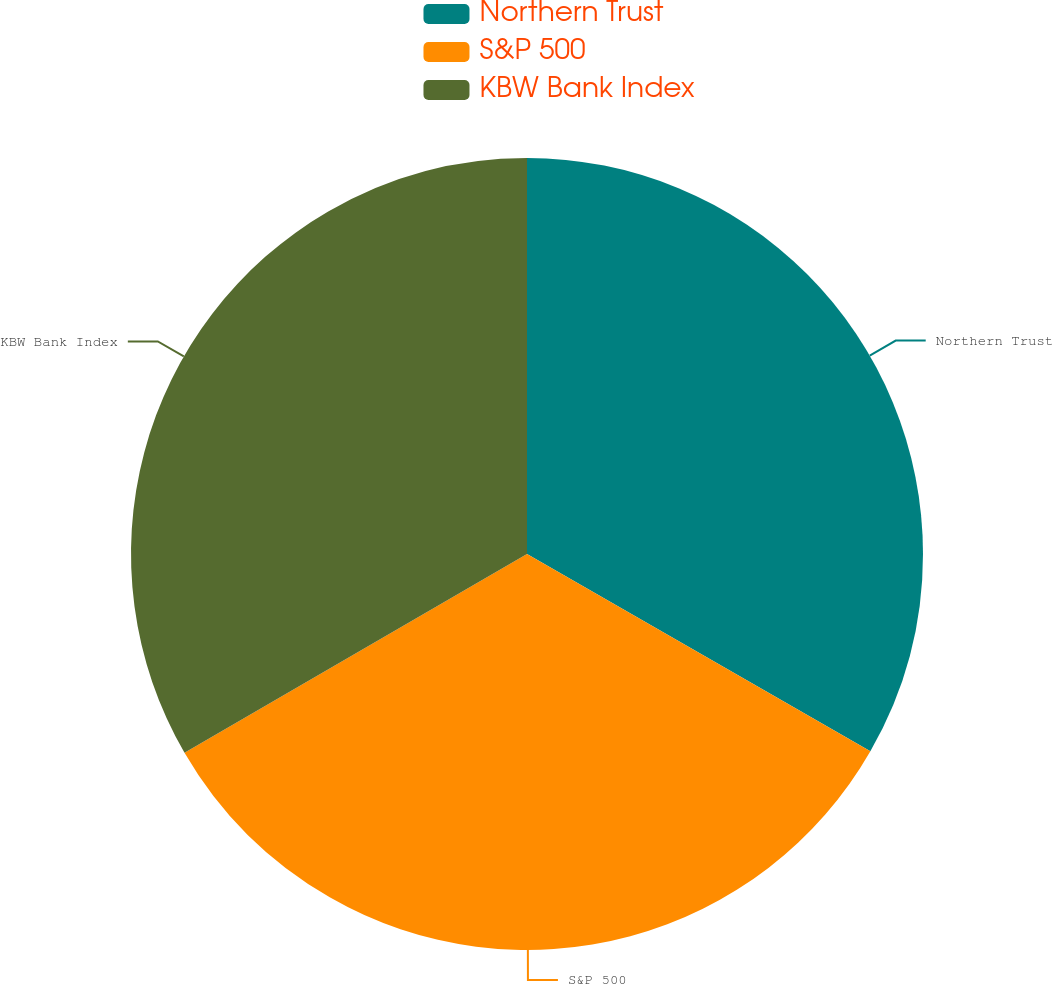Convert chart to OTSL. <chart><loc_0><loc_0><loc_500><loc_500><pie_chart><fcel>Northern Trust<fcel>S&P 500<fcel>KBW Bank Index<nl><fcel>33.3%<fcel>33.33%<fcel>33.37%<nl></chart> 